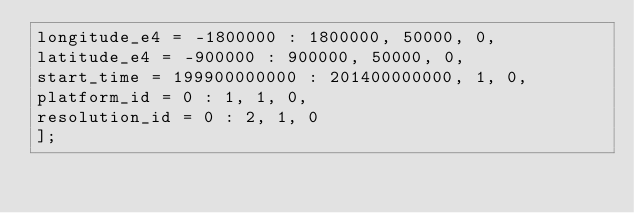Convert code to text. <code><loc_0><loc_0><loc_500><loc_500><_SQL_>longitude_e4 = -1800000 : 1800000, 50000, 0,
latitude_e4 = -900000 : 900000, 50000, 0,
start_time = 199900000000 : 201400000000, 1, 0,
platform_id = 0 : 1, 1, 0,
resolution_id = 0 : 2, 1, 0
];

</code> 